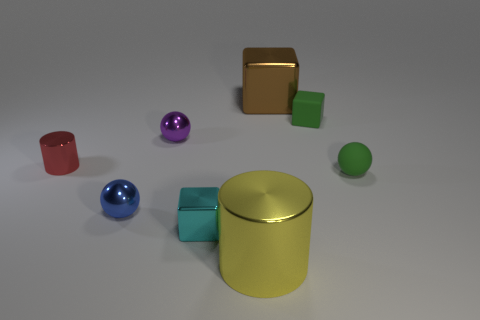Add 2 blue metal spheres. How many objects exist? 10 Subtract all spheres. How many objects are left? 5 Add 4 rubber balls. How many rubber balls are left? 5 Add 3 small blue shiny cylinders. How many small blue shiny cylinders exist? 3 Subtract 0 purple blocks. How many objects are left? 8 Subtract all brown rubber blocks. Subtract all cyan cubes. How many objects are left? 7 